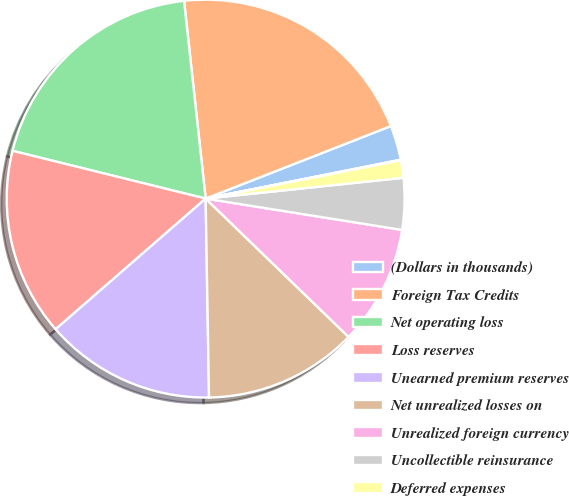<chart> <loc_0><loc_0><loc_500><loc_500><pie_chart><fcel>(Dollars in thousands)<fcel>Foreign Tax Credits<fcel>Net operating loss<fcel>Loss reserves<fcel>Unearned premium reserves<fcel>Net unrealized losses on<fcel>Unrealized foreign currency<fcel>Uncollectible reinsurance<fcel>Deferred expenses<fcel>Investment impairments<nl><fcel>2.81%<fcel>20.79%<fcel>19.41%<fcel>15.26%<fcel>13.87%<fcel>12.49%<fcel>9.72%<fcel>4.19%<fcel>1.42%<fcel>0.04%<nl></chart> 